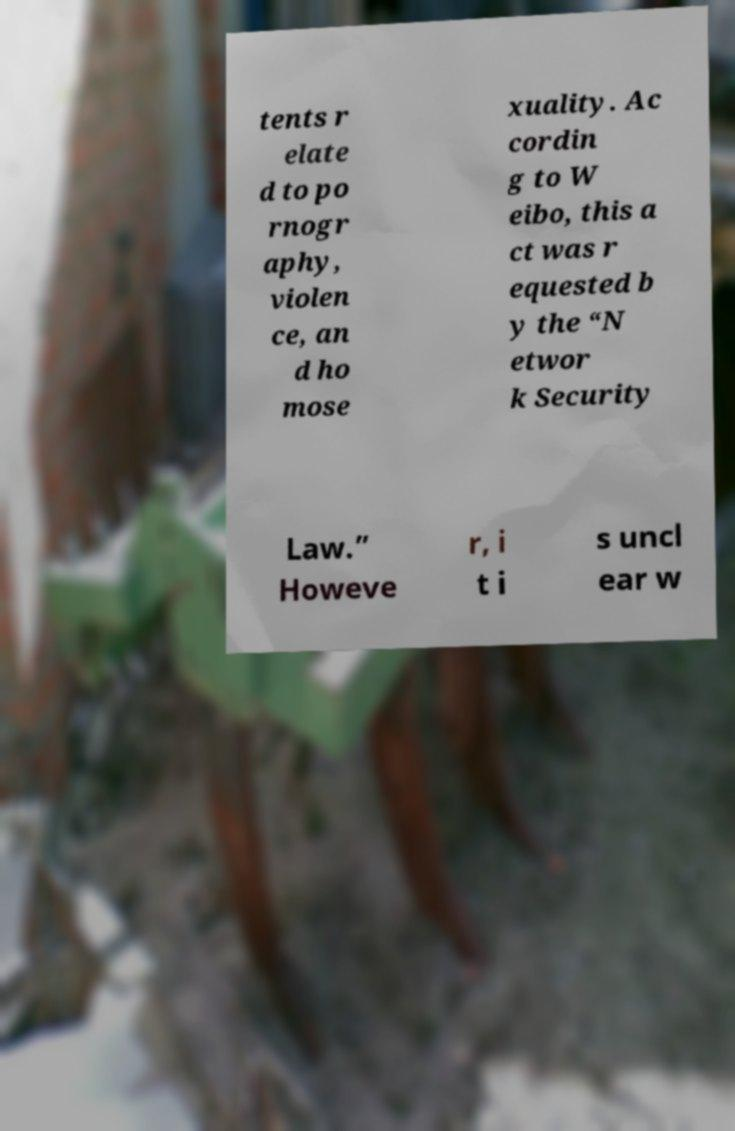Please read and relay the text visible in this image. What does it say? tents r elate d to po rnogr aphy, violen ce, an d ho mose xuality. Ac cordin g to W eibo, this a ct was r equested b y the “N etwor k Security Law.” Howeve r, i t i s uncl ear w 